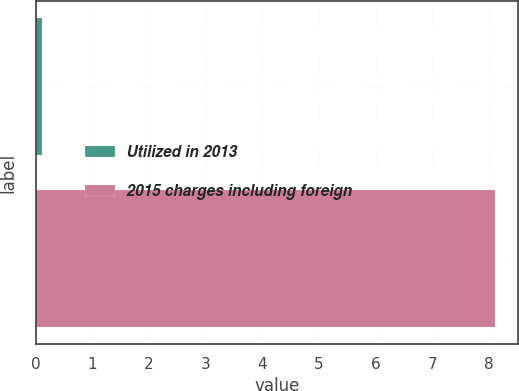Convert chart. <chart><loc_0><loc_0><loc_500><loc_500><bar_chart><fcel>Utilized in 2013<fcel>2015 charges including foreign<nl><fcel>0.1<fcel>8.1<nl></chart> 